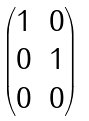<formula> <loc_0><loc_0><loc_500><loc_500>\begin{pmatrix} 1 & 0 \\ 0 & 1 \\ 0 & 0 \\ \end{pmatrix}</formula> 